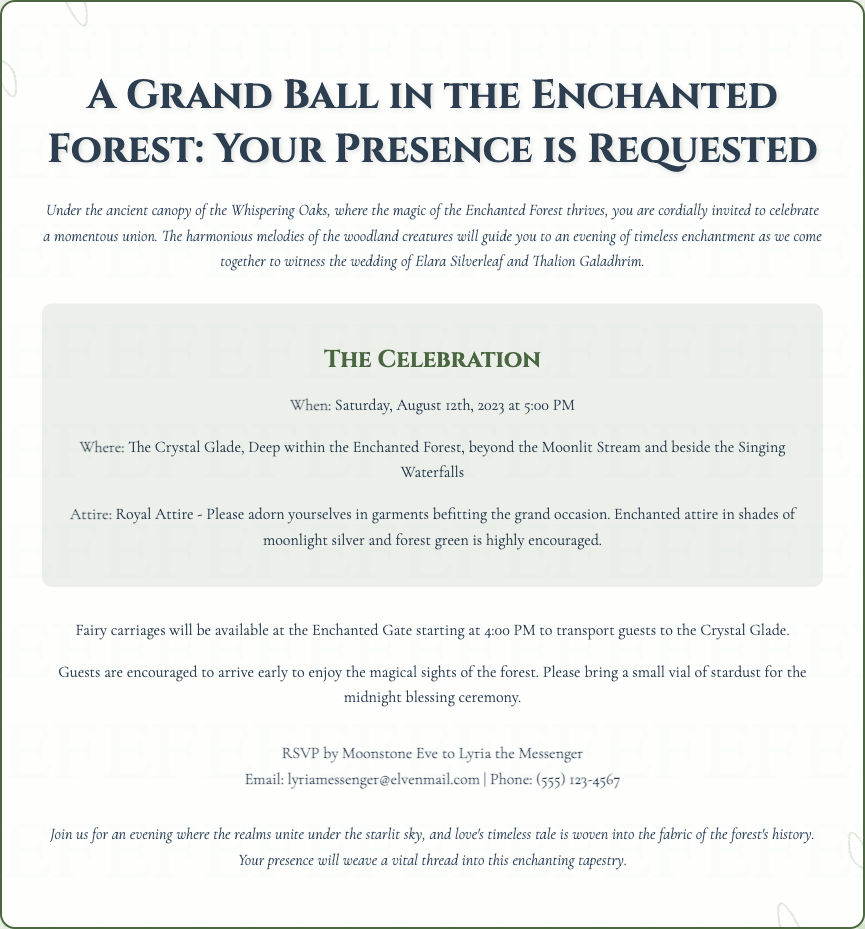What is the name of the couple getting married? The document specifies the names of the couple as Elara Silverleaf and Thalion Galadhrim.
Answer: Elara Silverleaf and Thalion Galadhrim When is the wedding ceremony taking place? The invitation provides the date of the ceremony as Saturday, August 12th, 2023 at 5:00 PM.
Answer: August 12th, 2023 What is the location of the wedding? The document states that the wedding will be held at The Crystal Glade, Deep within the Enchanted Forest.
Answer: The Crystal Glade What type of attire is requested for the event? The invitation mentions that guests should wear Royal Attire, specifically in shades of moonlight silver and forest green.
Answer: Royal Attire What time will fairy carriages start transporting guests? The invitation indicates that fairy carriages will be available starting at 4:00 PM.
Answer: 4:00 PM What do guests need to bring for the midnight blessing ceremony? The document requests that guests bring a small vial of stardust for the ceremony.
Answer: Small vial of stardust Who should guests contact to RSVP? The invitation specifies that guests should RSVP to Lyria the Messenger.
Answer: Lyria the Messenger What is the email provided for RSVP? The document provides the email address as lyriamessenger@elvenmail.com.
Answer: lyriamessenger@elvenmail.com What kind of setting is described for the wedding? The invitation describes the setting as under the ancient canopy of the Whispering Oaks in the Enchanted Forest.
Answer: Enchanted Forest 